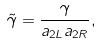Convert formula to latex. <formula><loc_0><loc_0><loc_500><loc_500>\tilde { \gamma } = \frac { \gamma } { a _ { 2 L } a _ { 2 R } } ,</formula> 